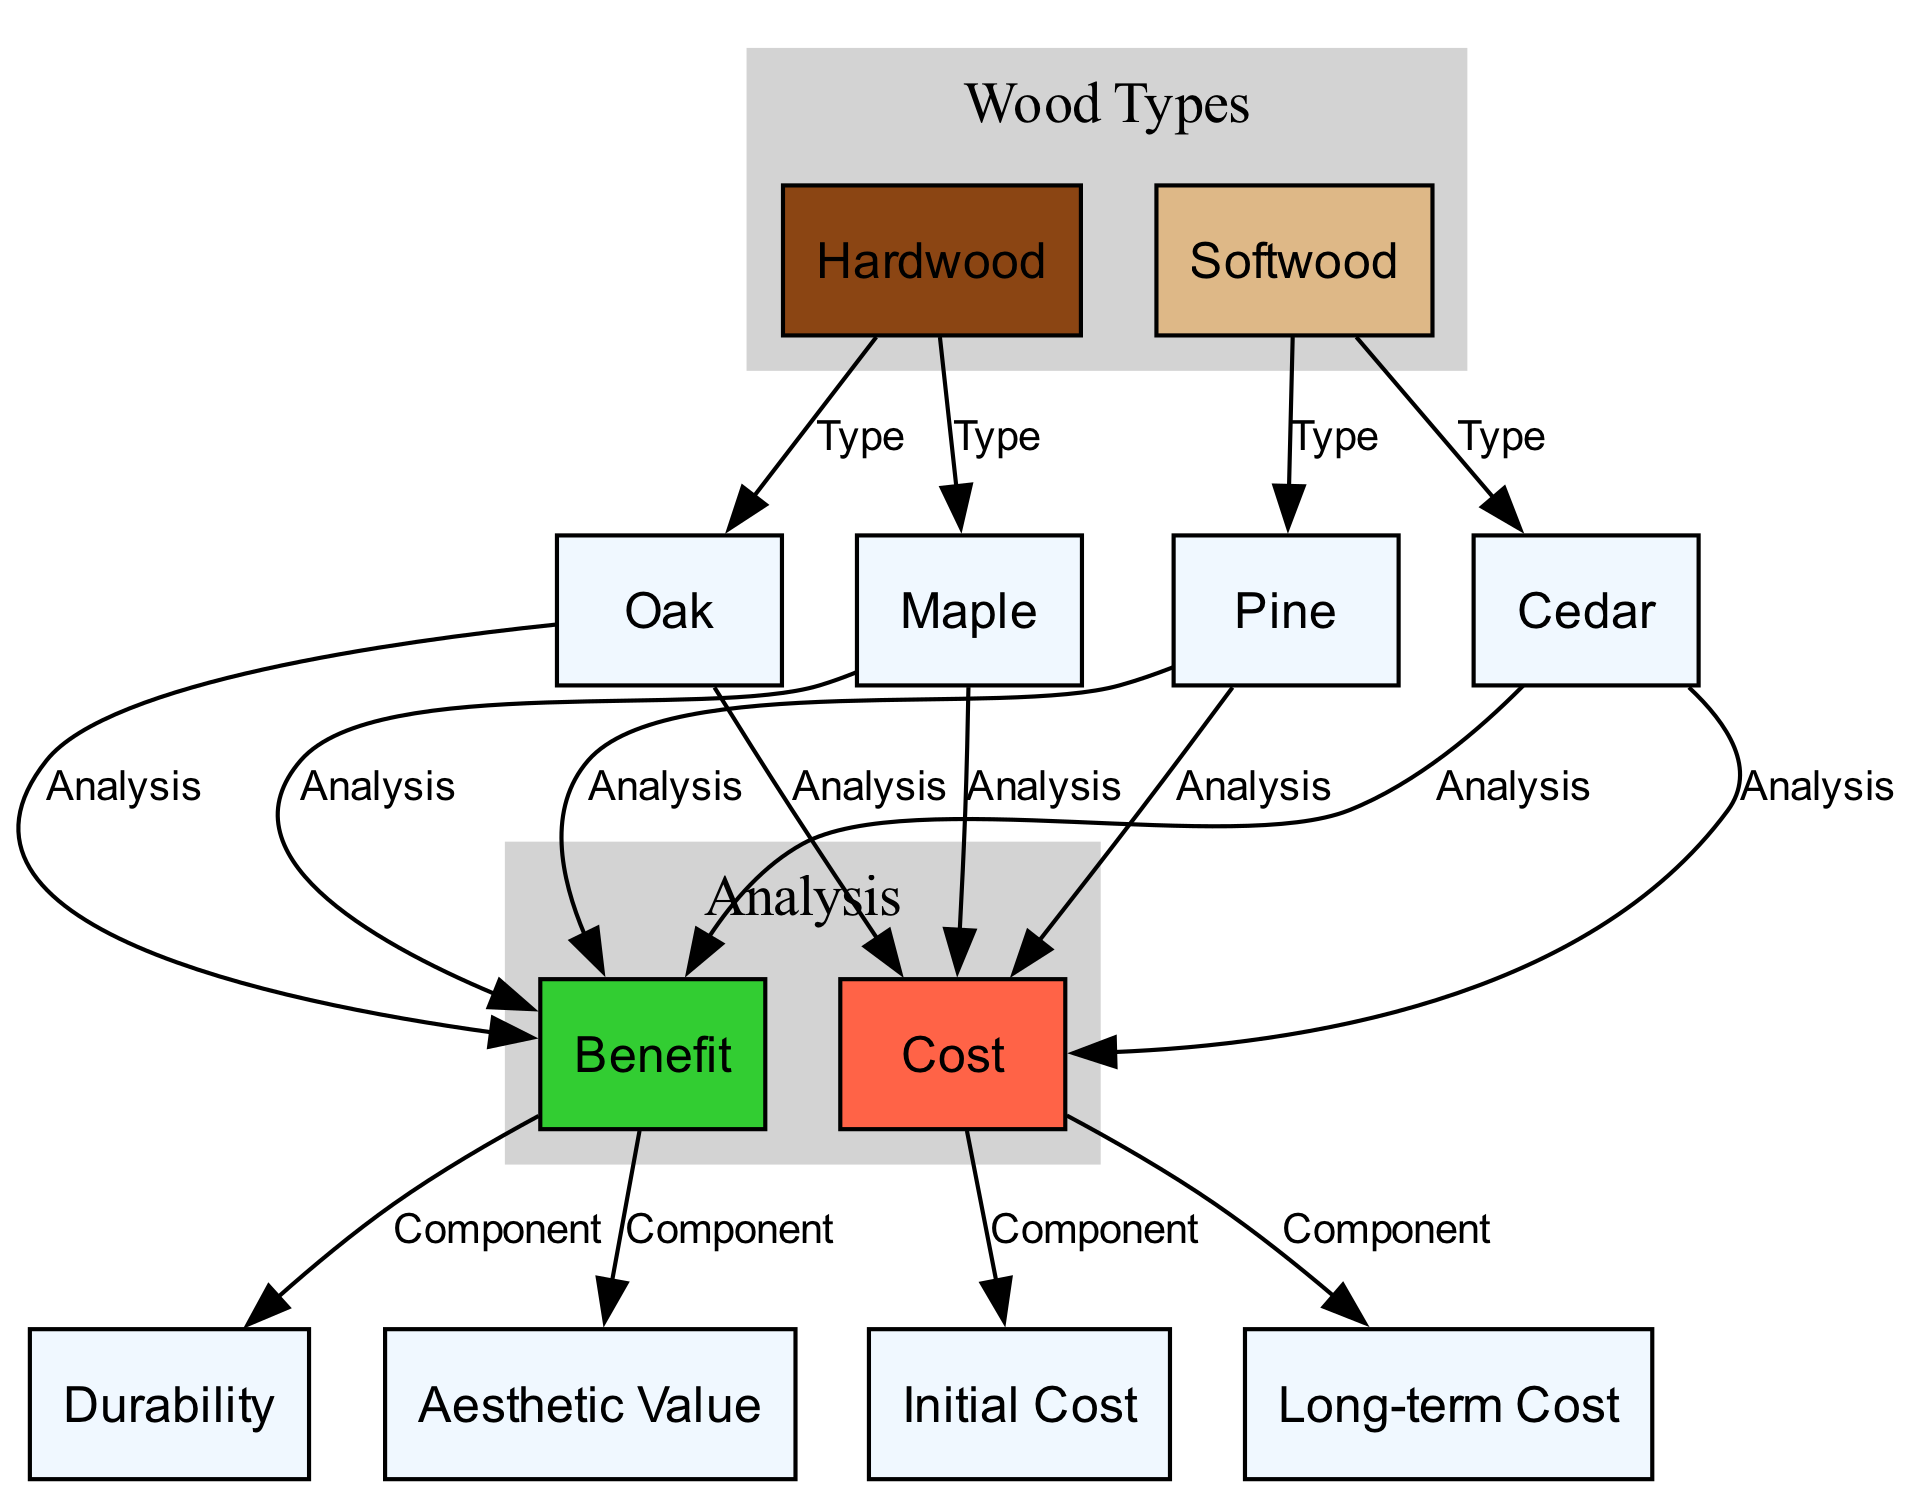What are the two main types of wood listed? The diagram shows two main types of wood: Hardwood and Softwood, represented as distinct nodes.
Answer: Hardwood and Softwood How many types of hardwood are presented in the diagram? The diagram indicates that there are two types of hardwood: Oak and Maple. This can be counted from the connections leading from the Hardwood node.
Answer: Two Which wood type is associated with durability as a benefit? The diagram shows a direct connection from the Benefit node to the Durability component, confirming that all referenced wood types share durability as a benefit.
Answer: All wood types What is the initial cost category related to in the diagram? The diagram connects the Cost node to the Initial Cost category, indicating that Initial Cost is a component of the overall cost analysis.
Answer: Cost Which type of wood has the highest aesthetic value? The diagram illustrates that all wood types connect to the Aesthetic Value component, but it does not explicitly rank them, so further context is needed to determine which has the highest.
Answer: Not specified If the initial cost of oak is high, what could be concluded about its long-term cost? The diagram suggests that while Initial Cost is high, it may lead to low long-term costs due to durability as a benefit, which is indicated in the Benefits analysis.
Answer: Potentially low long-term cost What color represents the benefit category in the diagram? The benefit category is illustrated in lime green, which is designated by the node's fill color in the diagram.
Answer: Lime Green How many edges connect the hardwood type to specific wood types? There are a total of two edges that connect the Hardwood node to its specific types – Oak and Maple.
Answer: Two edges 